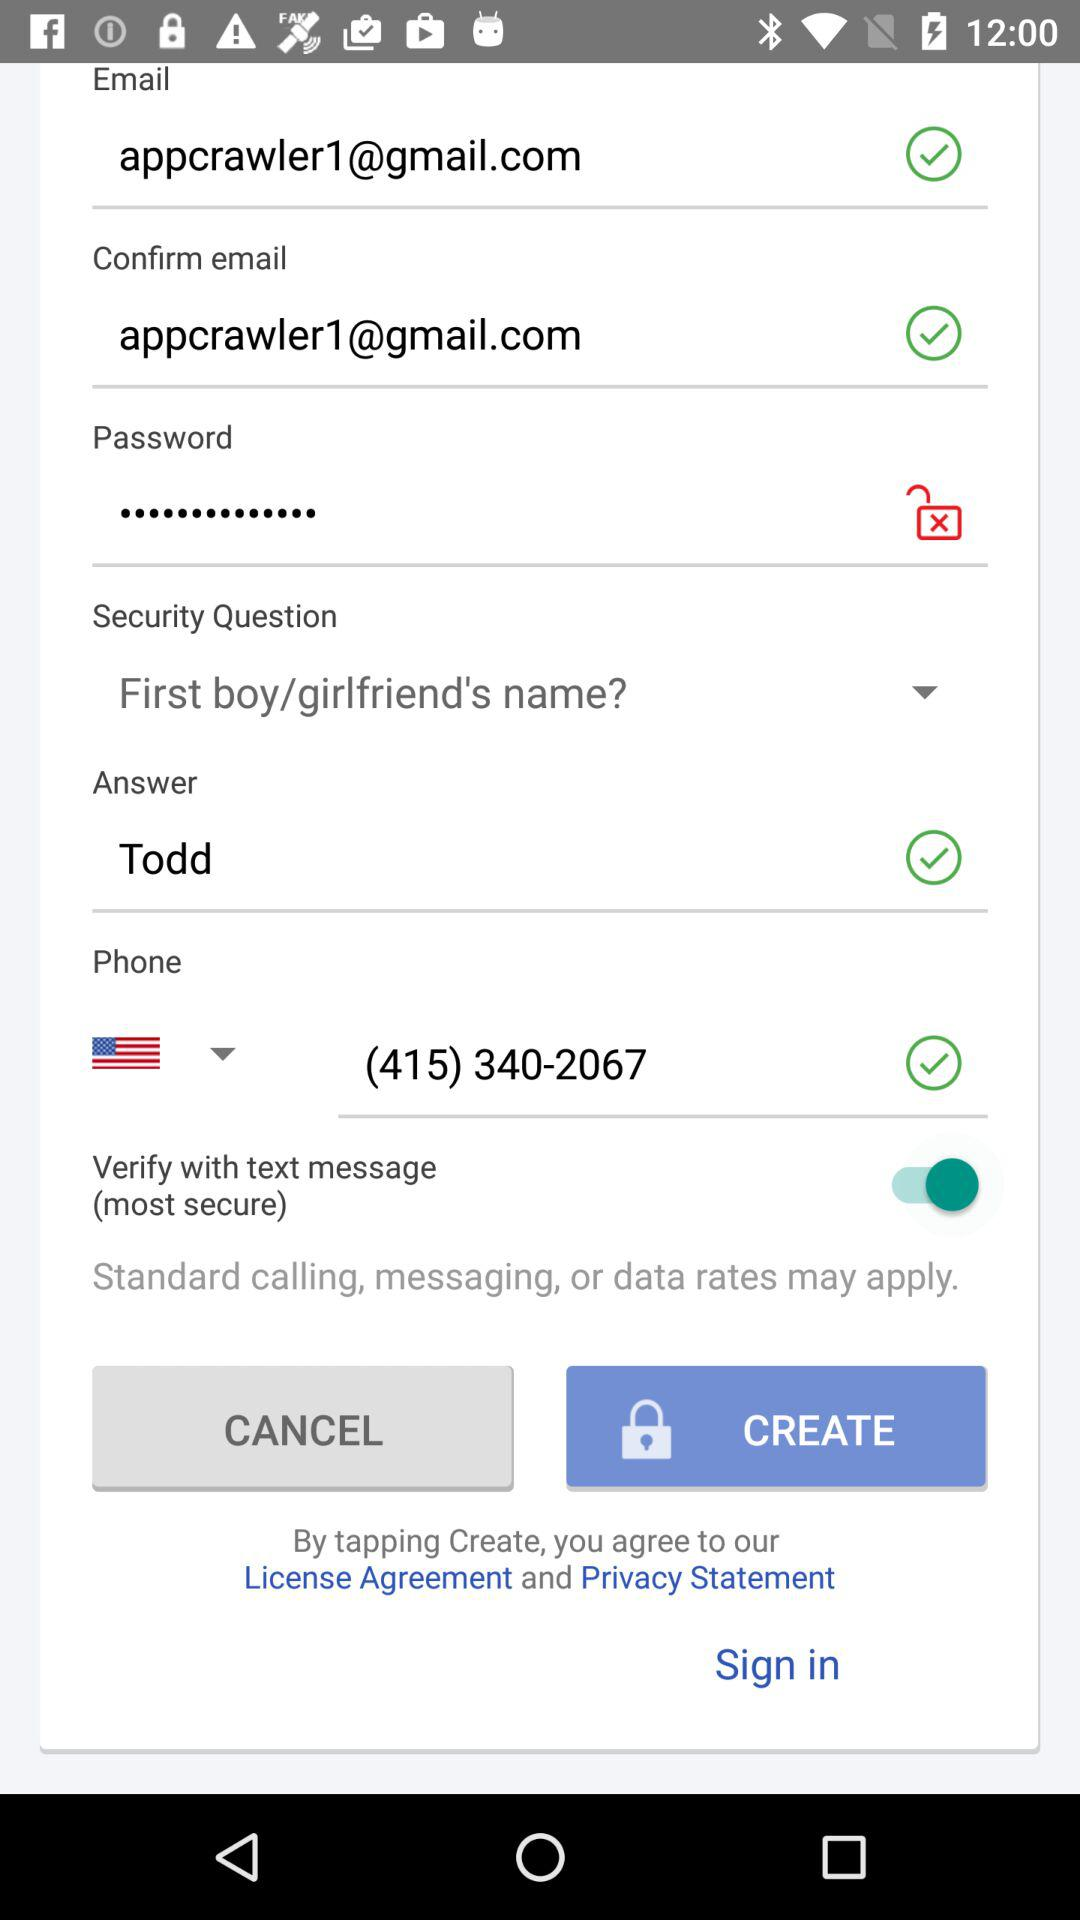What is the security question? The security question is "First boy/girlfriend's name?". 